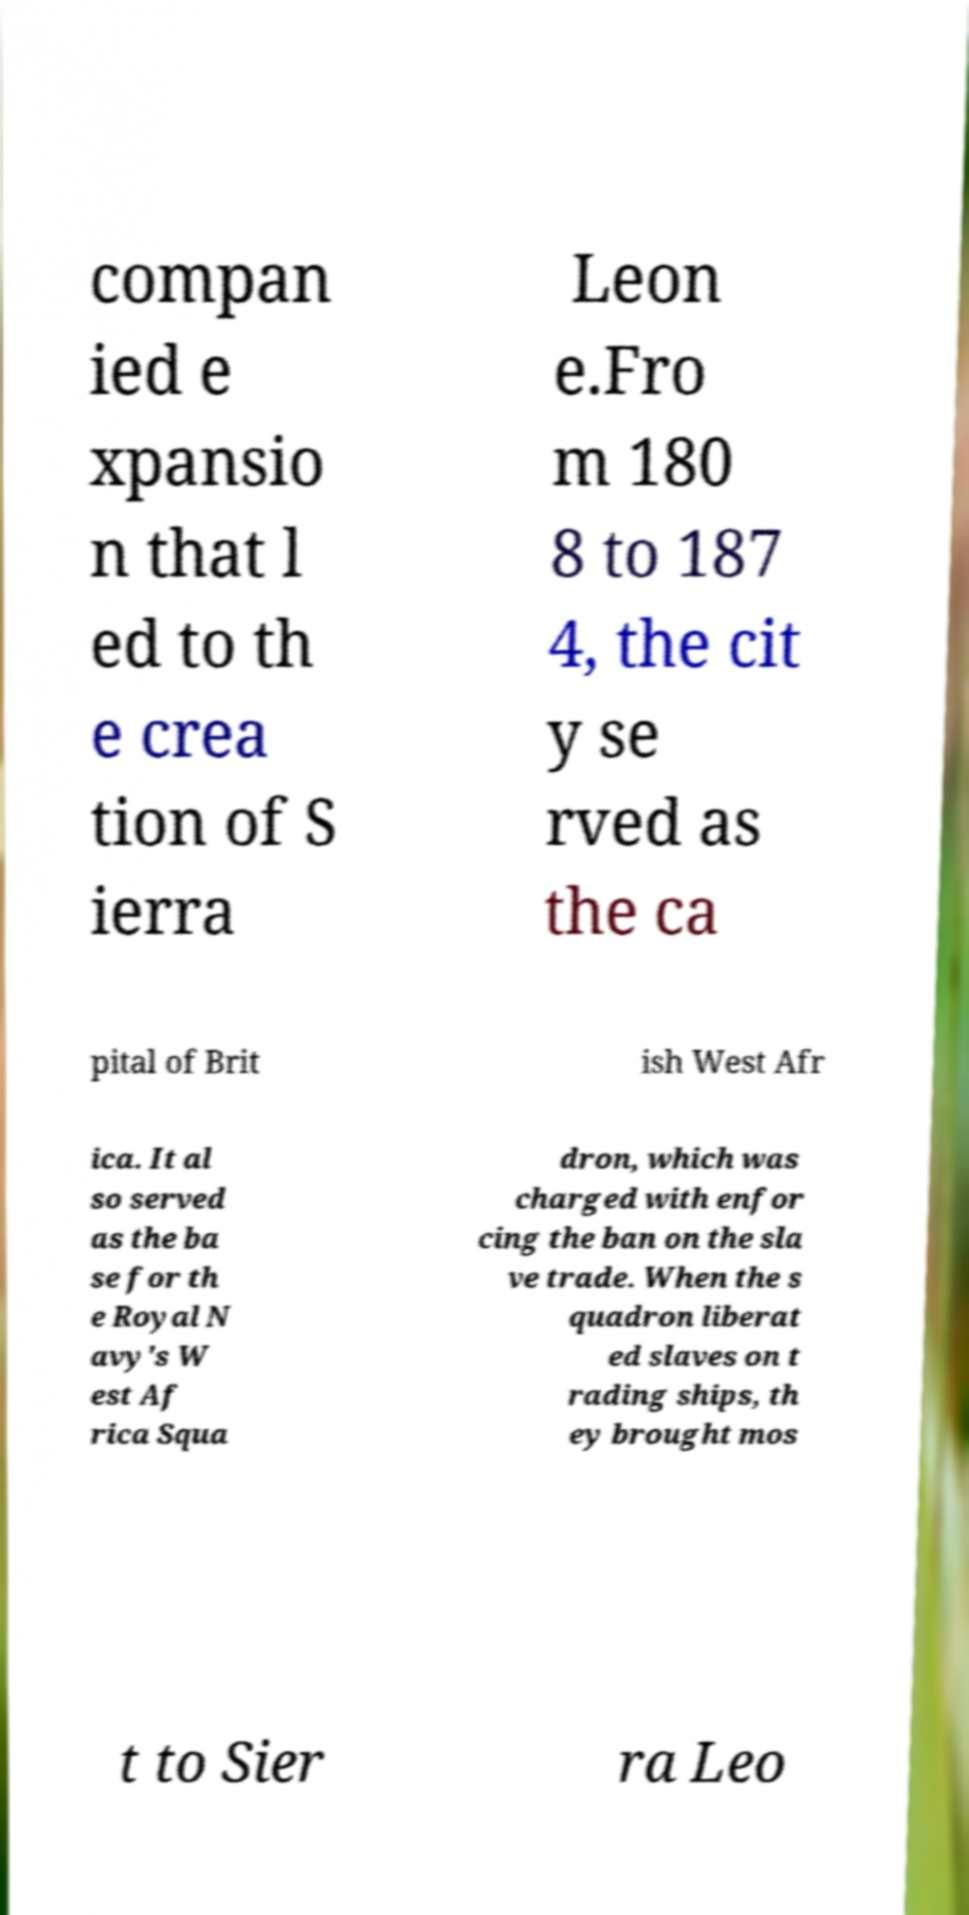Please identify and transcribe the text found in this image. compan ied e xpansio n that l ed to th e crea tion of S ierra Leon e.Fro m 180 8 to 187 4, the cit y se rved as the ca pital of Brit ish West Afr ica. It al so served as the ba se for th e Royal N avy's W est Af rica Squa dron, which was charged with enfor cing the ban on the sla ve trade. When the s quadron liberat ed slaves on t rading ships, th ey brought mos t to Sier ra Leo 